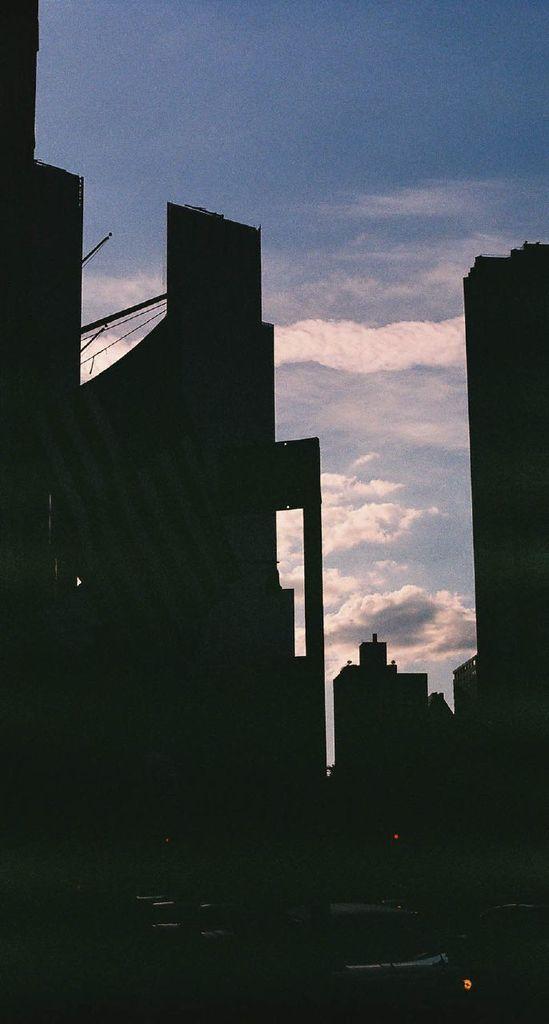Can you describe this image briefly? In this picture I can see buildings and the sky in the background. 